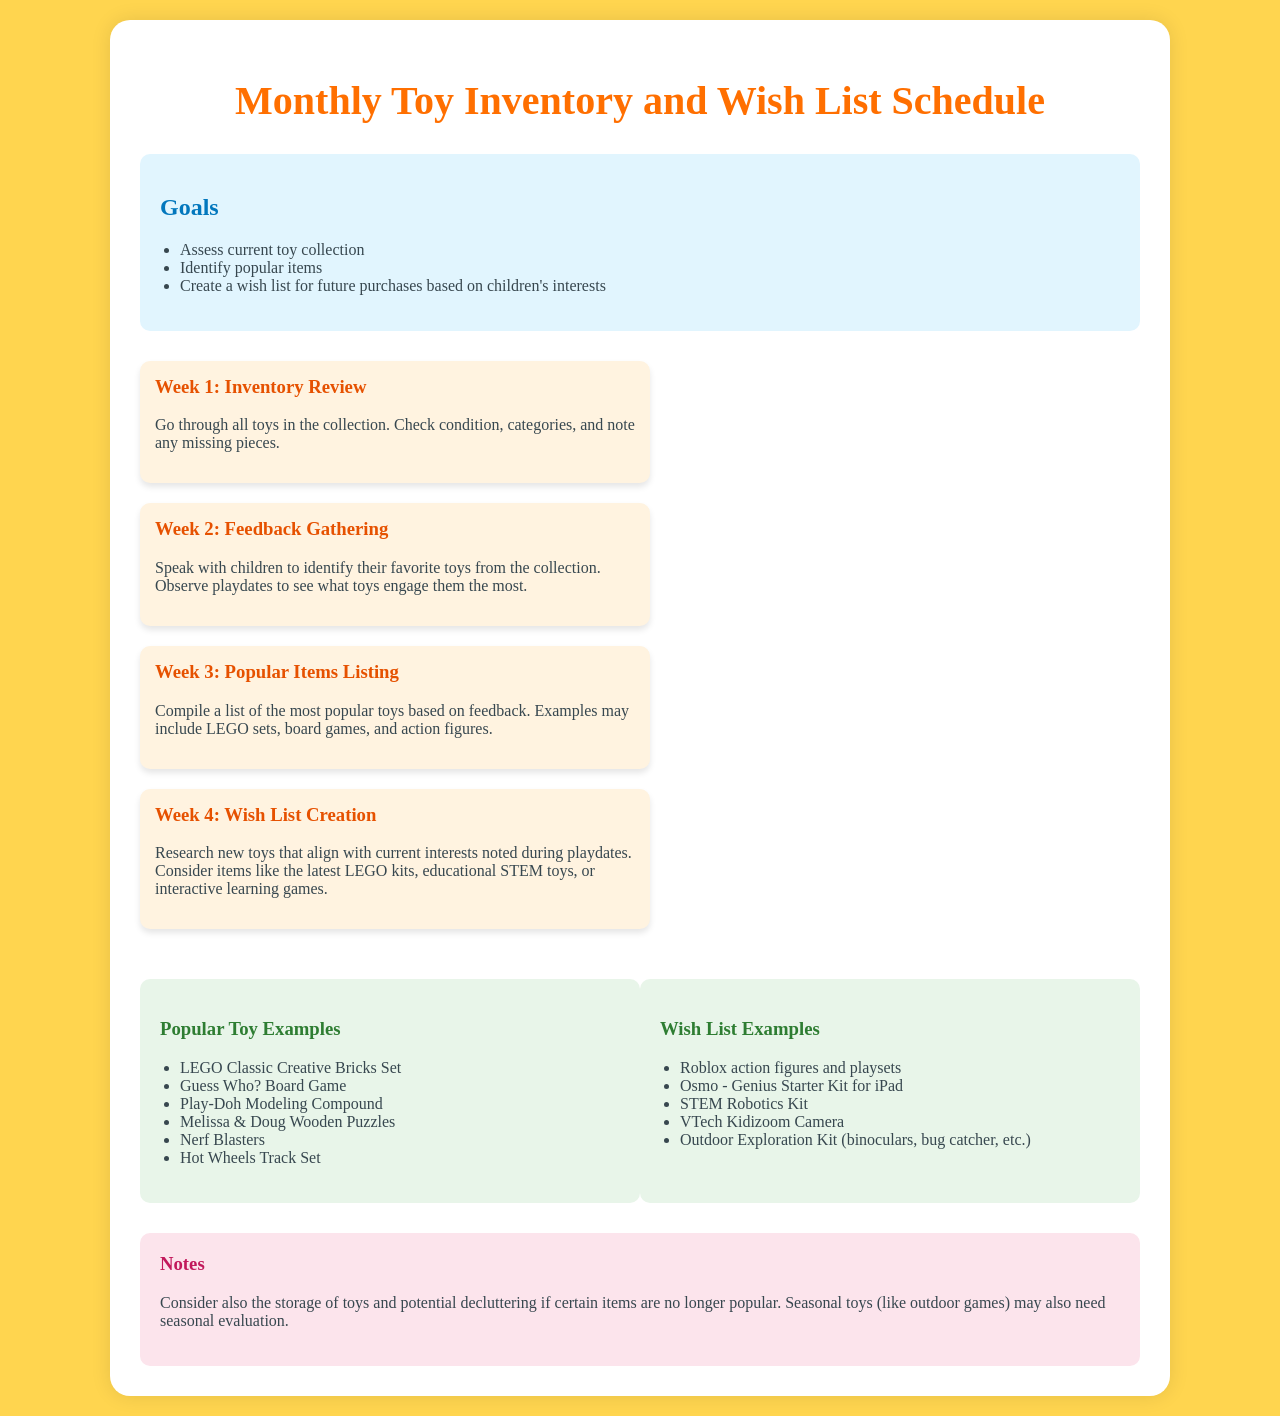What is the main title of the document? The main title is mentioned at the top of the document and indicates the purpose and content of the schedule.
Answer: Monthly Toy Inventory and Wish List Schedule How many weeks are outlined in the schedule? The document specifies a four-week schedule for the toy inventory and wish list process.
Answer: 4 What is the goal of the second week? The goal of the second week is to gather information from children regarding their favorite toys.
Answer: Feedback Gathering Name one of the popular toy examples listed in the document. The document provides several examples of popular toys that have been noted, which can be any of them.
Answer: LEGO Classic Creative Bricks Set What type of toy is suggested for the wish list related to outdoor activities? The wish list includes a toy that encourages exploration and outdoor activities.
Answer: Outdoor Exploration Kit During which week should popular items be listed? The schedule indicates that the compilation of popular items should occur during a specific week.
Answer: Week 3 What color is used for the background of the goals section? The document mentions the color of the background used in the goals section to visually distinguish it.
Answer: Light blue What is suggested for  the wish list in terms of technology? The document lists a specific technological toy that is recommended for the wish list.
Answer: Osmo - Genius Starter Kit for iPad 